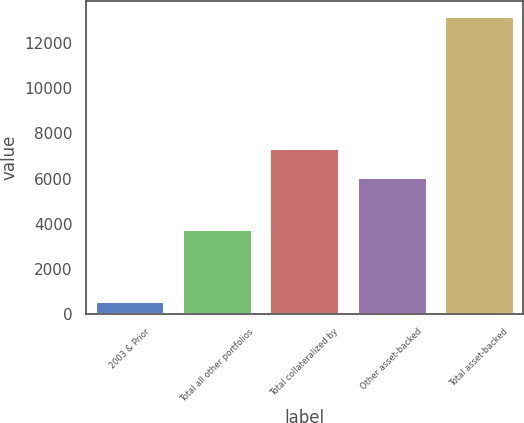<chart> <loc_0><loc_0><loc_500><loc_500><bar_chart><fcel>2003 & Prior<fcel>Total all other portfolios<fcel>Total collateralized by<fcel>Other asset-backed<fcel>Total asset-backed<nl><fcel>576<fcel>3771<fcel>7337.3<fcel>6074<fcel>13209<nl></chart> 